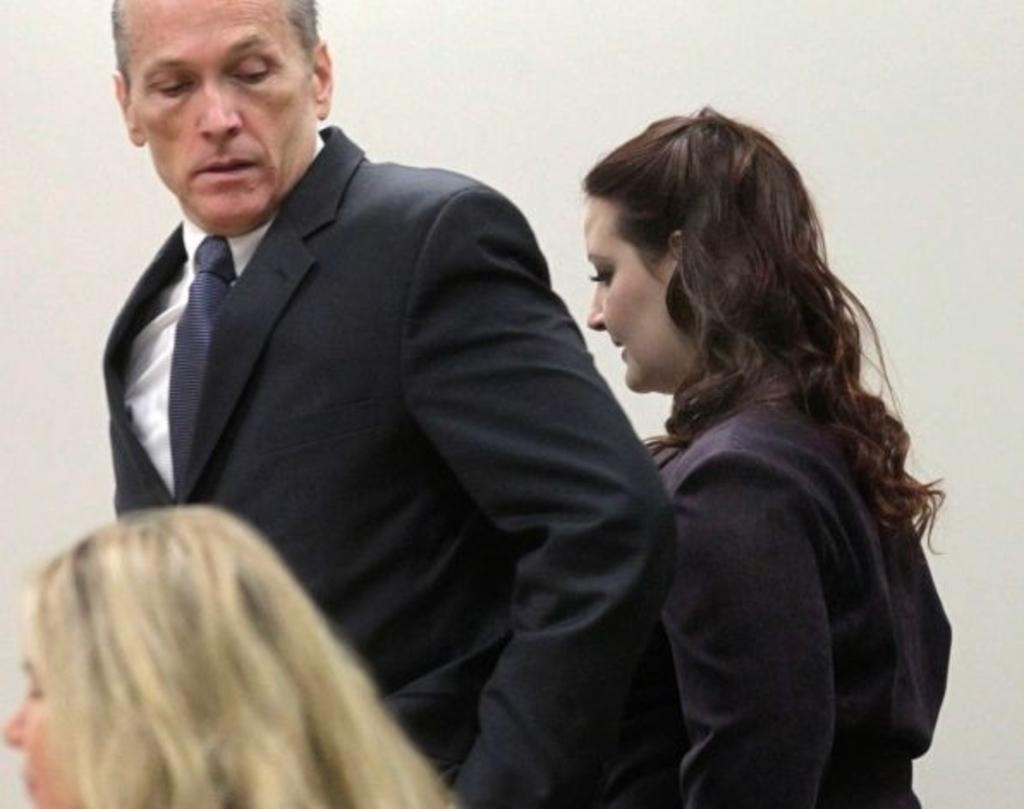Describe this image in one or two sentences. In the center of the image there are persons. In the background there is a wall. 